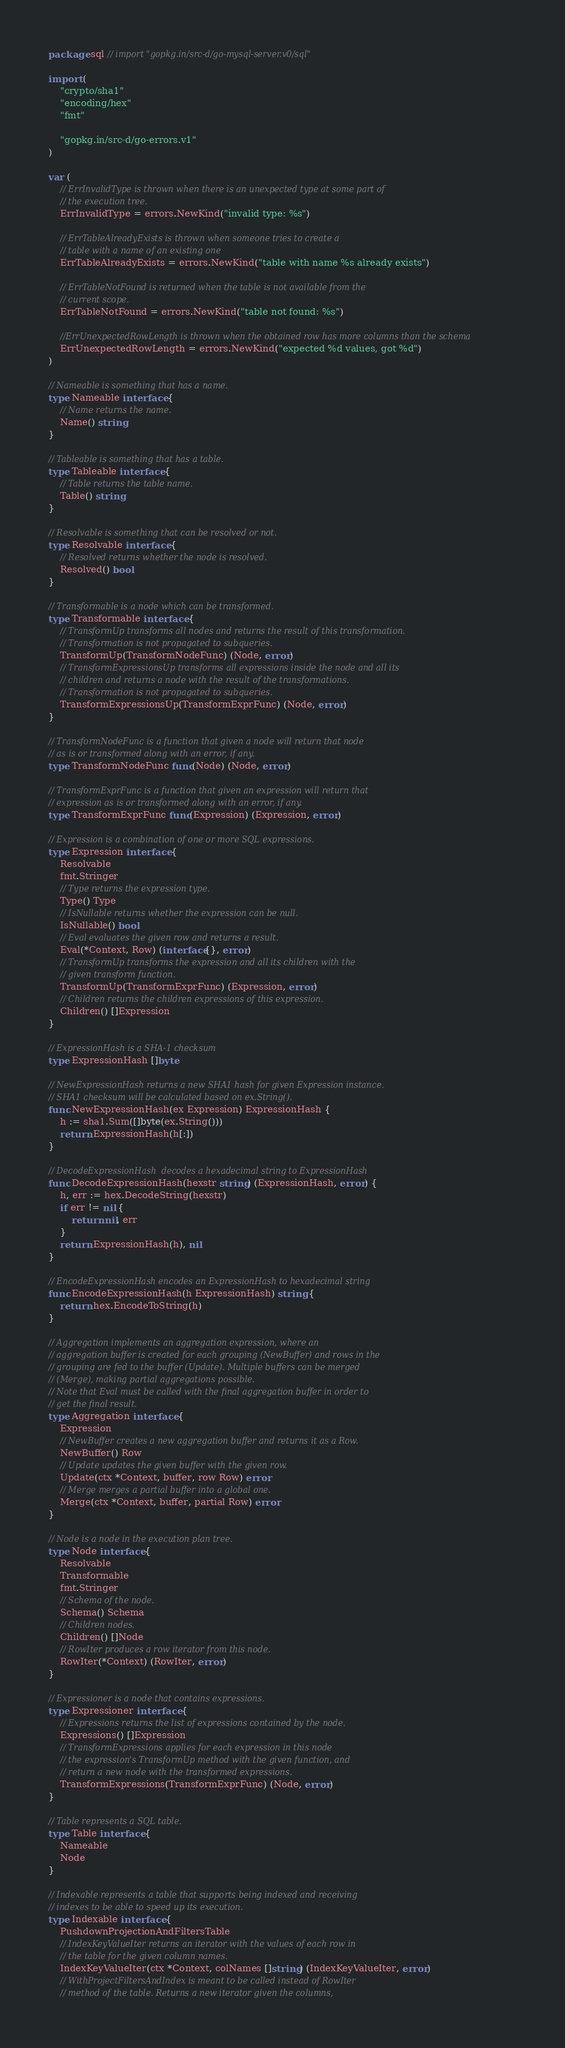Convert code to text. <code><loc_0><loc_0><loc_500><loc_500><_Go_>package sql // import "gopkg.in/src-d/go-mysql-server.v0/sql"

import (
	"crypto/sha1"
	"encoding/hex"
	"fmt"

	"gopkg.in/src-d/go-errors.v1"
)

var (
	// ErrInvalidType is thrown when there is an unexpected type at some part of
	// the execution tree.
	ErrInvalidType = errors.NewKind("invalid type: %s")

	// ErrTableAlreadyExists is thrown when someone tries to create a
	// table with a name of an existing one
	ErrTableAlreadyExists = errors.NewKind("table with name %s already exists")

	// ErrTableNotFound is returned when the table is not available from the
	// current scope.
	ErrTableNotFound = errors.NewKind("table not found: %s")

	//ErrUnexpectedRowLength is thrown when the obtained row has more columns than the schema
	ErrUnexpectedRowLength = errors.NewKind("expected %d values, got %d")
)

// Nameable is something that has a name.
type Nameable interface {
	// Name returns the name.
	Name() string
}

// Tableable is something that has a table.
type Tableable interface {
	// Table returns the table name.
	Table() string
}

// Resolvable is something that can be resolved or not.
type Resolvable interface {
	// Resolved returns whether the node is resolved.
	Resolved() bool
}

// Transformable is a node which can be transformed.
type Transformable interface {
	// TransformUp transforms all nodes and returns the result of this transformation.
	// Transformation is not propagated to subqueries.
	TransformUp(TransformNodeFunc) (Node, error)
	// TransformExpressionsUp transforms all expressions inside the node and all its
	// children and returns a node with the result of the transformations.
	// Transformation is not propagated to subqueries.
	TransformExpressionsUp(TransformExprFunc) (Node, error)
}

// TransformNodeFunc is a function that given a node will return that node
// as is or transformed along with an error, if any.
type TransformNodeFunc func(Node) (Node, error)

// TransformExprFunc is a function that given an expression will return that
// expression as is or transformed along with an error, if any.
type TransformExprFunc func(Expression) (Expression, error)

// Expression is a combination of one or more SQL expressions.
type Expression interface {
	Resolvable
	fmt.Stringer
	// Type returns the expression type.
	Type() Type
	// IsNullable returns whether the expression can be null.
	IsNullable() bool
	// Eval evaluates the given row and returns a result.
	Eval(*Context, Row) (interface{}, error)
	// TransformUp transforms the expression and all its children with the
	// given transform function.
	TransformUp(TransformExprFunc) (Expression, error)
	// Children returns the children expressions of this expression.
	Children() []Expression
}

// ExpressionHash is a SHA-1 checksum
type ExpressionHash []byte

// NewExpressionHash returns a new SHA1 hash for given Expression instance.
// SHA1 checksum will be calculated based on ex.String().
func NewExpressionHash(ex Expression) ExpressionHash {
	h := sha1.Sum([]byte(ex.String()))
	return ExpressionHash(h[:])
}

// DecodeExpressionHash  decodes a hexadecimal string to ExpressionHash
func DecodeExpressionHash(hexstr string) (ExpressionHash, error) {
	h, err := hex.DecodeString(hexstr)
	if err != nil {
		return nil, err
	}
	return ExpressionHash(h), nil
}

// EncodeExpressionHash encodes an ExpressionHash to hexadecimal string
func EncodeExpressionHash(h ExpressionHash) string {
	return hex.EncodeToString(h)
}

// Aggregation implements an aggregation expression, where an
// aggregation buffer is created for each grouping (NewBuffer) and rows in the
// grouping are fed to the buffer (Update). Multiple buffers can be merged
// (Merge), making partial aggregations possible.
// Note that Eval must be called with the final aggregation buffer in order to
// get the final result.
type Aggregation interface {
	Expression
	// NewBuffer creates a new aggregation buffer and returns it as a Row.
	NewBuffer() Row
	// Update updates the given buffer with the given row.
	Update(ctx *Context, buffer, row Row) error
	// Merge merges a partial buffer into a global one.
	Merge(ctx *Context, buffer, partial Row) error
}

// Node is a node in the execution plan tree.
type Node interface {
	Resolvable
	Transformable
	fmt.Stringer
	// Schema of the node.
	Schema() Schema
	// Children nodes.
	Children() []Node
	// RowIter produces a row iterator from this node.
	RowIter(*Context) (RowIter, error)
}

// Expressioner is a node that contains expressions.
type Expressioner interface {
	// Expressions returns the list of expressions contained by the node.
	Expressions() []Expression
	// TransformExpressions applies for each expression in this node
	// the expression's TransformUp method with the given function, and
	// return a new node with the transformed expressions.
	TransformExpressions(TransformExprFunc) (Node, error)
}

// Table represents a SQL table.
type Table interface {
	Nameable
	Node
}

// Indexable represents a table that supports being indexed and receiving
// indexes to be able to speed up its execution.
type Indexable interface {
	PushdownProjectionAndFiltersTable
	// IndexKeyValueIter returns an iterator with the values of each row in
	// the table for the given column names.
	IndexKeyValueIter(ctx *Context, colNames []string) (IndexKeyValueIter, error)
	// WithProjectFiltersAndIndex is meant to be called instead of RowIter
	// method of the table. Returns a new iterator given the columns,</code> 